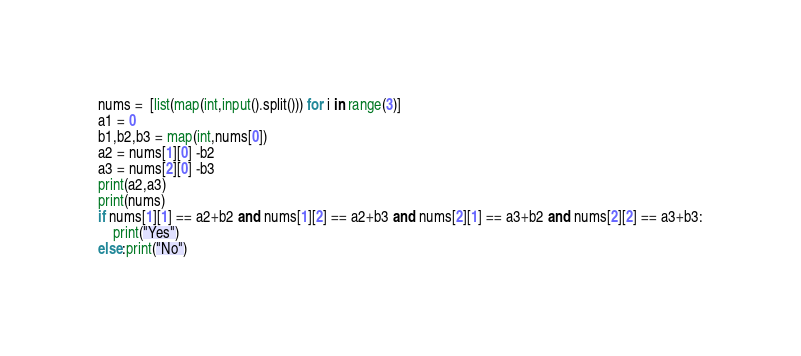<code> <loc_0><loc_0><loc_500><loc_500><_Python_>nums =  [list(map(int,input().split())) for i in range(3)]
a1 = 0
b1,b2,b3 = map(int,nums[0])
a2 = nums[1][0] -b2
a3 = nums[2][0] -b3
print(a2,a3)
print(nums)
if nums[1][1] == a2+b2 and nums[1][2] == a2+b3 and nums[2][1] == a3+b2 and nums[2][2] == a3+b3:
    print("Yes")
else:print("No")
</code> 